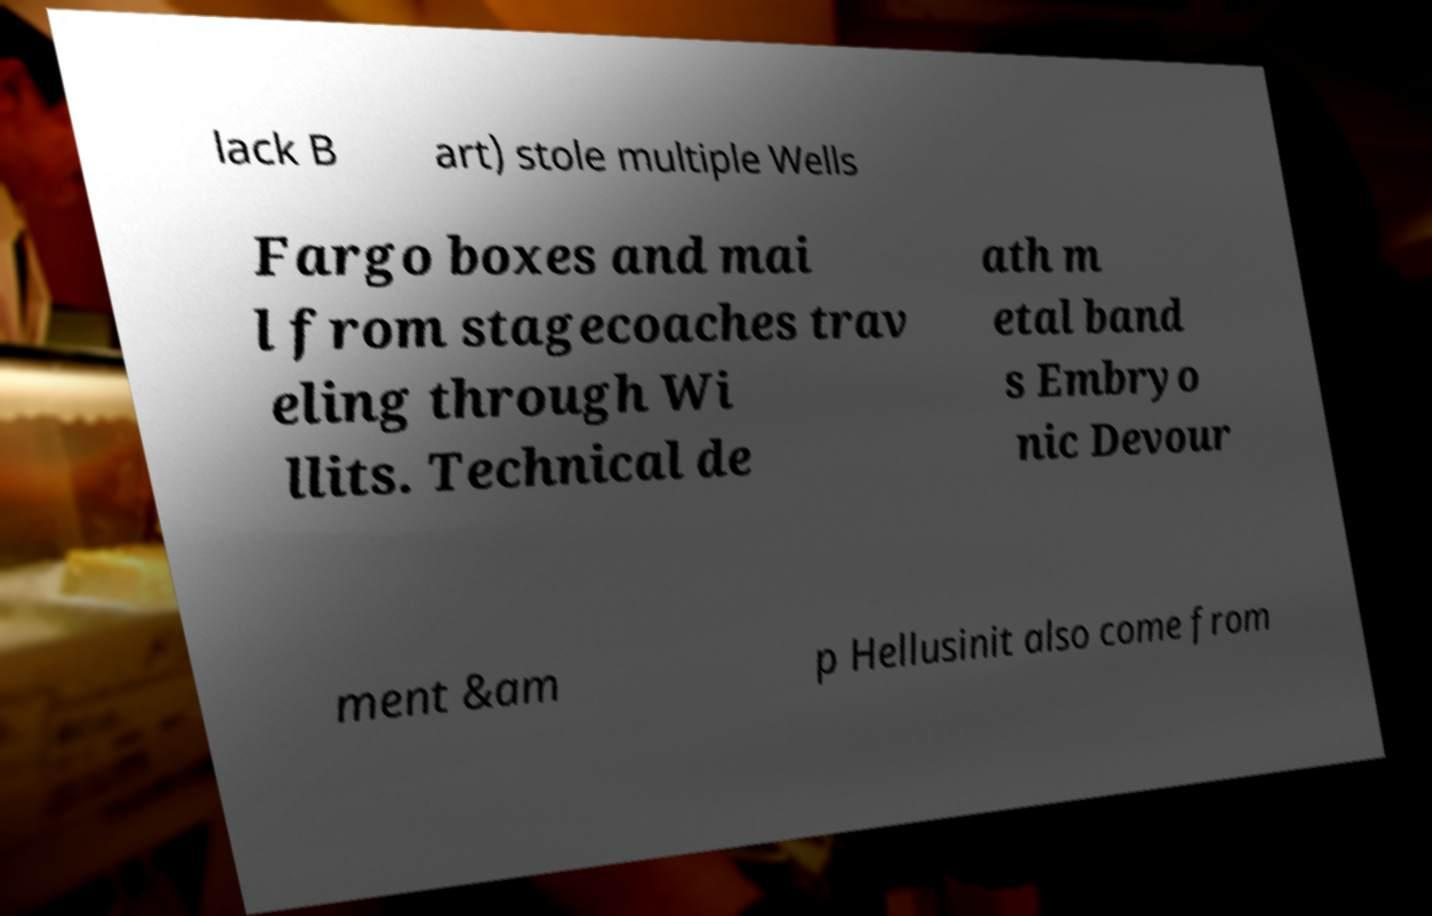Please read and relay the text visible in this image. What does it say? lack B art) stole multiple Wells Fargo boxes and mai l from stagecoaches trav eling through Wi llits. Technical de ath m etal band s Embryo nic Devour ment &am p Hellusinit also come from 